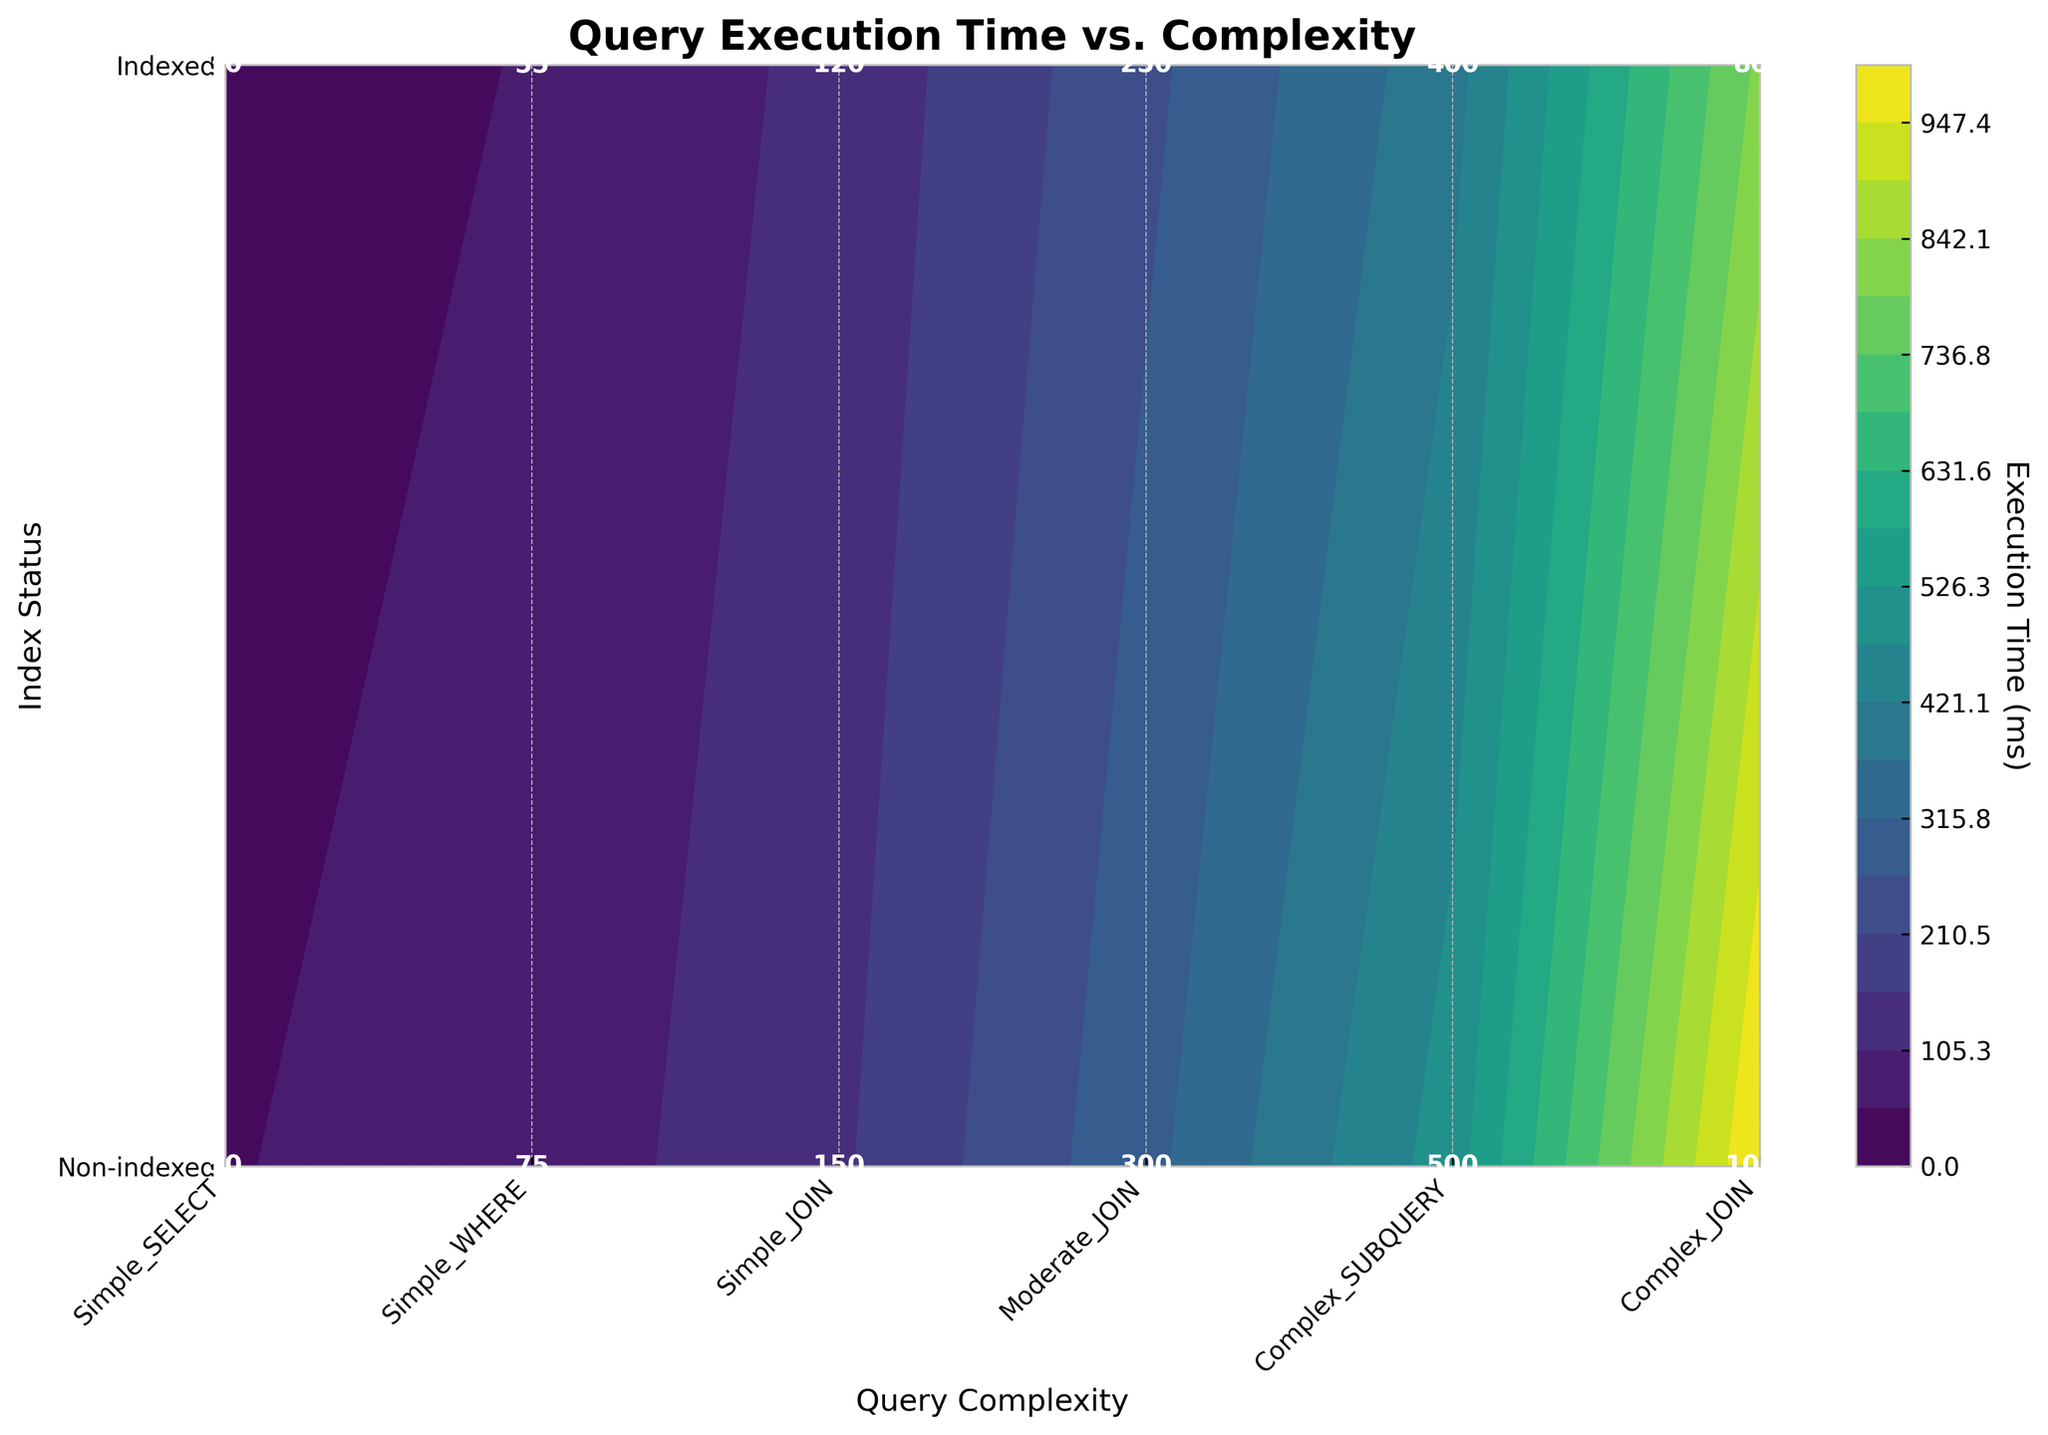What's the title of the figure? The title of the plot is displayed at the top center of the figure, which usually indicates the main subject or the data being visualized.
Answer: Query Execution Time vs. Complexity What does the color transition in the figure represent? The color transition in the contour plot indicates different levels of query execution time; lighter colors depict shorter execution times, while darker colors represent longer execution times.
Answer: Execution Time (ms) How many data points are there for indexed queries? For indexed queries, the y-axis label "Indexed" corresponds to y = 1. There are six data points ranging from 'Simple_SELECT_indexed' to 'Complex_JOIN_indexed'.
Answer: 6 What is the execution time for a 'Complex_SUBQUERY' in a non-indexed environment? Look at the contour plot where x corresponds to 'Complex_SUBQUERY' and y is 'Non-indexed'. The value at that intersection or the annotation provides the execution time.
Answer: 500 ms Which query complexity shows the largest execution time reduction after indexing? Compare the execution times of non-indexed and indexed queries for each complexity level. Identify the complexity with the highest difference. Calculations show 'Complex_JOIN' has the highest reduction (1000 ms - 800 ms = 200 ms).
Answer: Complex_JOIN Which query complexity has the least execution time when indexed? Find the smallest execution time in the row where y = 1 ('Indexed'). The smallest value corresponds to 'Simple_SELECT_indexed'.
Answer: Simple_SELECT What is the difference in execution times for 'Moderate_JOIN' between indexed and non-indexed? Locate 'Moderate_JOIN' values in both indexed and non-indexed rows and subtract the indexed value from the non-indexed value (300 ms - 250 ms).
Answer: 50 ms What is the average execution time for 'Simple_JOIN' queries? Calculate the average of both 'Simple_JOIN' and 'Simple_JOIN_indexed' execution times (150 ms and 120 ms). (150 + 120) / 2 = 135 ms.
Answer: 135 ms Which type of query complexity doesn't benefit significantly from indexing based on execution time? Compare paired execution times for each query, focusing on identifying minimal differences, indicating little performance gain. 'Simple_SELECT' shows minimal benefit (50 ms vs 30 ms).
Answer: Simple_SELECT At what execution time level does 'Simple_JOIN_indexed' reside? Check the contour and annotations for 'Simple_JOIN' in the indexed row. The specified value is directly annotated in the plot.
Answer: 120 ms 